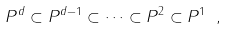Convert formula to latex. <formula><loc_0><loc_0><loc_500><loc_500>P ^ { d } \subset P ^ { d - 1 } \subset \dots \subset P ^ { 2 } \subset P ^ { 1 } \ ,</formula> 